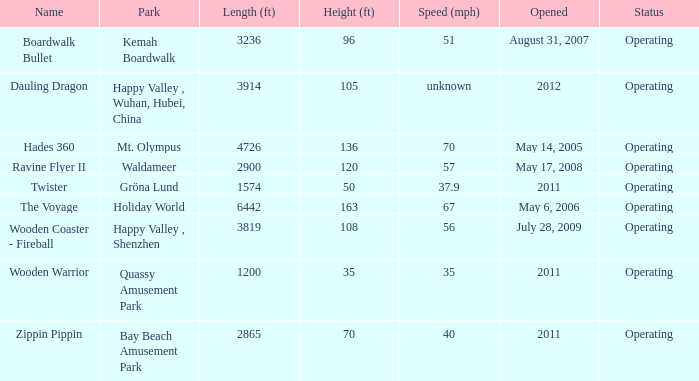Would you mind parsing the complete table? {'header': ['Name', 'Park', 'Length (ft)', 'Height (ft)', 'Speed (mph)', 'Opened', 'Status'], 'rows': [['Boardwalk Bullet', 'Kemah Boardwalk', '3236', '96', '51', 'August 31, 2007', 'Operating'], ['Dauling Dragon', 'Happy Valley , Wuhan, Hubei, China', '3914', '105', 'unknown', '2012', 'Operating'], ['Hades 360', 'Mt. Olympus', '4726', '136', '70', 'May 14, 2005', 'Operating'], ['Ravine Flyer II', 'Waldameer', '2900', '120', '57', 'May 17, 2008', 'Operating'], ['Twister', 'Gröna Lund', '1574', '50', '37.9', '2011', 'Operating'], ['The Voyage', 'Holiday World', '6442', '163', '67', 'May 6, 2006', 'Operating'], ['Wooden Coaster - Fireball', 'Happy Valley , Shenzhen', '3819', '108', '56', 'July 28, 2009', 'Operating'], ['Wooden Warrior', 'Quassy Amusement Park', '1200', '35', '35', '2011', 'Operating'], ['Zippin Pippin', 'Bay Beach Amusement Park', '2865', '70', '40', '2011', 'Operating']]} How many parks is Zippin Pippin located in 1.0. 